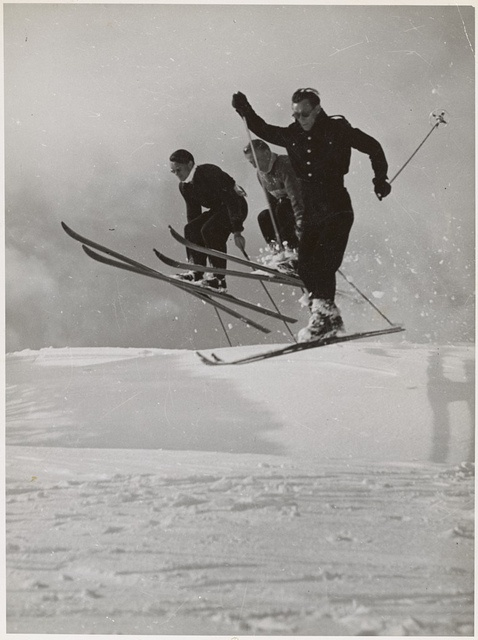Describe the objects in this image and their specific colors. I can see people in lightgray, black, gray, and darkgray tones, people in lightgray, black, darkgray, and gray tones, people in lightgray, black, gray, and darkgray tones, skis in lightgray, gray, and black tones, and skis in lightgray, gray, darkgray, and black tones in this image. 